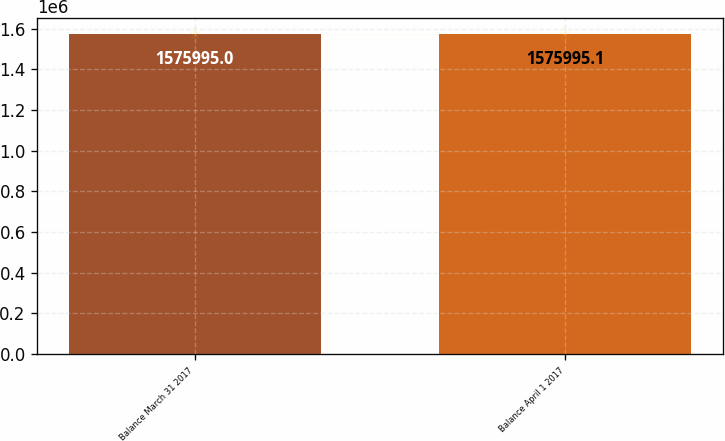<chart> <loc_0><loc_0><loc_500><loc_500><bar_chart><fcel>Balance March 31 2017<fcel>Balance April 1 2017<nl><fcel>1.576e+06<fcel>1.576e+06<nl></chart> 